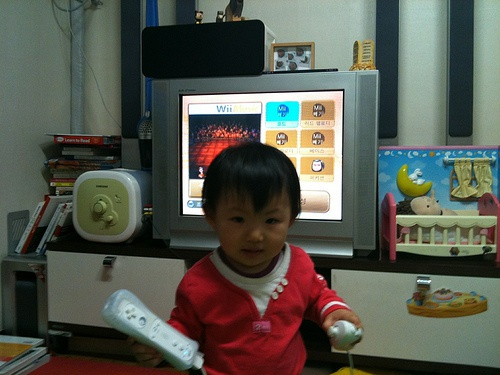Describe the objects in this image and their specific colors. I can see tv in gray, black, and ivory tones, people in gray, black, maroon, and brown tones, remote in gray, lightblue, darkgray, and teal tones, book in gray, black, and maroon tones, and remote in gray, darkgray, darkgreen, and black tones in this image. 